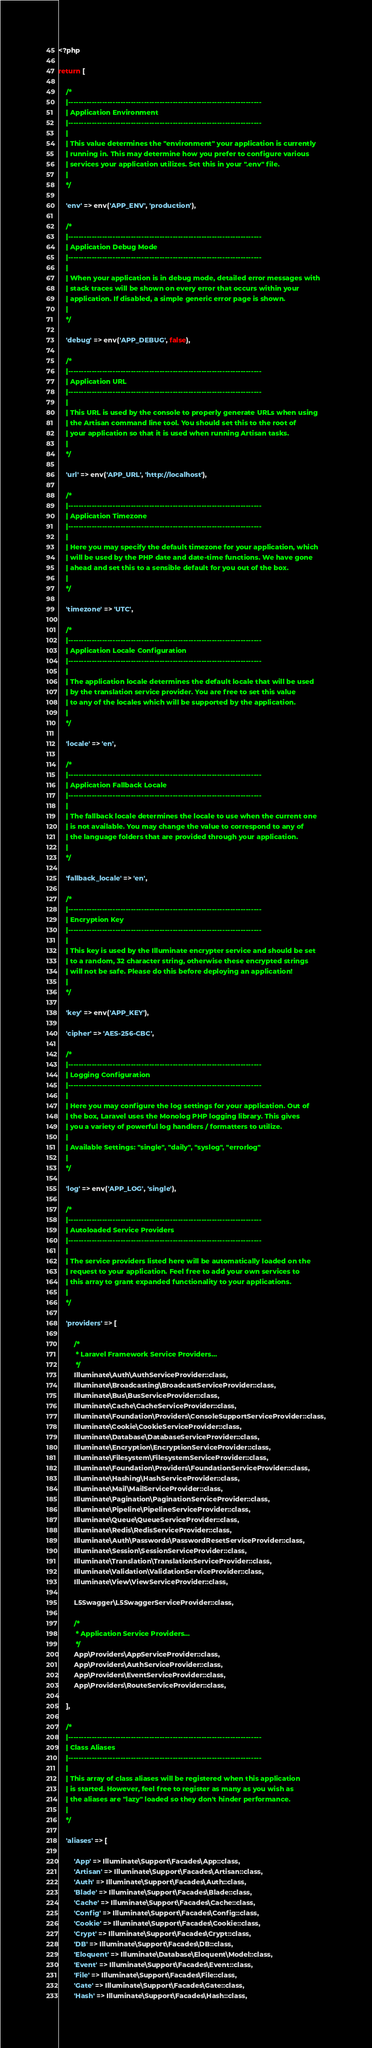Convert code to text. <code><loc_0><loc_0><loc_500><loc_500><_PHP_><?php

return [

    /*
    |--------------------------------------------------------------------------
    | Application Environment
    |--------------------------------------------------------------------------
    |
    | This value determines the "environment" your application is currently
    | running in. This may determine how you prefer to configure various
    | services your application utilizes. Set this in your ".env" file.
    |
    */

    'env' => env('APP_ENV', 'production'),

    /*
    |--------------------------------------------------------------------------
    | Application Debug Mode
    |--------------------------------------------------------------------------
    |
    | When your application is in debug mode, detailed error messages with
    | stack traces will be shown on every error that occurs within your
    | application. If disabled, a simple generic error page is shown.
    |
    */

    'debug' => env('APP_DEBUG', false),

    /*
    |--------------------------------------------------------------------------
    | Application URL
    |--------------------------------------------------------------------------
    |
    | This URL is used by the console to properly generate URLs when using
    | the Artisan command line tool. You should set this to the root of
    | your application so that it is used when running Artisan tasks.
    |
    */

    'url' => env('APP_URL', 'http://localhost'),

    /*
    |--------------------------------------------------------------------------
    | Application Timezone
    |--------------------------------------------------------------------------
    |
    | Here you may specify the default timezone for your application, which
    | will be used by the PHP date and date-time functions. We have gone
    | ahead and set this to a sensible default for you out of the box.
    |
    */

    'timezone' => 'UTC',

    /*
    |--------------------------------------------------------------------------
    | Application Locale Configuration
    |--------------------------------------------------------------------------
    |
    | The application locale determines the default locale that will be used
    | by the translation service provider. You are free to set this value
    | to any of the locales which will be supported by the application.
    |
    */

    'locale' => 'en',

    /*
    |--------------------------------------------------------------------------
    | Application Fallback Locale
    |--------------------------------------------------------------------------
    |
    | The fallback locale determines the locale to use when the current one
    | is not available. You may change the value to correspond to any of
    | the language folders that are provided through your application.
    |
    */

    'fallback_locale' => 'en',

    /*
    |--------------------------------------------------------------------------
    | Encryption Key
    |--------------------------------------------------------------------------
    |
    | This key is used by the Illuminate encrypter service and should be set
    | to a random, 32 character string, otherwise these encrypted strings
    | will not be safe. Please do this before deploying an application!
    |
    */

    'key' => env('APP_KEY'),

    'cipher' => 'AES-256-CBC',

    /*
    |--------------------------------------------------------------------------
    | Logging Configuration
    |--------------------------------------------------------------------------
    |
    | Here you may configure the log settings for your application. Out of
    | the box, Laravel uses the Monolog PHP logging library. This gives
    | you a variety of powerful log handlers / formatters to utilize.
    |
    | Available Settings: "single", "daily", "syslog", "errorlog"
    |
    */

    'log' => env('APP_LOG', 'single'),

    /*
    |--------------------------------------------------------------------------
    | Autoloaded Service Providers
    |--------------------------------------------------------------------------
    |
    | The service providers listed here will be automatically loaded on the
    | request to your application. Feel free to add your own services to
    | this array to grant expanded functionality to your applications.
    |
    */

    'providers' => [

        /*
         * Laravel Framework Service Providers...
         */
        Illuminate\Auth\AuthServiceProvider::class,
        Illuminate\Broadcasting\BroadcastServiceProvider::class,
        Illuminate\Bus\BusServiceProvider::class,
        Illuminate\Cache\CacheServiceProvider::class,
        Illuminate\Foundation\Providers\ConsoleSupportServiceProvider::class,
        Illuminate\Cookie\CookieServiceProvider::class,
        Illuminate\Database\DatabaseServiceProvider::class,
        Illuminate\Encryption\EncryptionServiceProvider::class,
        Illuminate\Filesystem\FilesystemServiceProvider::class,
        Illuminate\Foundation\Providers\FoundationServiceProvider::class,
        Illuminate\Hashing\HashServiceProvider::class,
        Illuminate\Mail\MailServiceProvider::class,
        Illuminate\Pagination\PaginationServiceProvider::class,
        Illuminate\Pipeline\PipelineServiceProvider::class,
        Illuminate\Queue\QueueServiceProvider::class,
        Illuminate\Redis\RedisServiceProvider::class,
        Illuminate\Auth\Passwords\PasswordResetServiceProvider::class,
        Illuminate\Session\SessionServiceProvider::class,
        Illuminate\Translation\TranslationServiceProvider::class,
        Illuminate\Validation\ValidationServiceProvider::class,
        Illuminate\View\ViewServiceProvider::class,
        
        L5Swagger\L5SwaggerServiceProvider::class,

        /*
         * Application Service Providers...
         */
        App\Providers\AppServiceProvider::class,
        App\Providers\AuthServiceProvider::class,
        App\Providers\EventServiceProvider::class,
        App\Providers\RouteServiceProvider::class,

    ],

    /*
    |--------------------------------------------------------------------------
    | Class Aliases
    |--------------------------------------------------------------------------
    |
    | This array of class aliases will be registered when this application
    | is started. However, feel free to register as many as you wish as
    | the aliases are "lazy" loaded so they don't hinder performance.
    |
    */

    'aliases' => [

        'App' => Illuminate\Support\Facades\App::class,
        'Artisan' => Illuminate\Support\Facades\Artisan::class,
        'Auth' => Illuminate\Support\Facades\Auth::class,
        'Blade' => Illuminate\Support\Facades\Blade::class,
        'Cache' => Illuminate\Support\Facades\Cache::class,
        'Config' => Illuminate\Support\Facades\Config::class,
        'Cookie' => Illuminate\Support\Facades\Cookie::class,
        'Crypt' => Illuminate\Support\Facades\Crypt::class,
        'DB' => Illuminate\Support\Facades\DB::class,
        'Eloquent' => Illuminate\Database\Eloquent\Model::class,
        'Event' => Illuminate\Support\Facades\Event::class,
        'File' => Illuminate\Support\Facades\File::class,
        'Gate' => Illuminate\Support\Facades\Gate::class,
        'Hash' => Illuminate\Support\Facades\Hash::class,</code> 